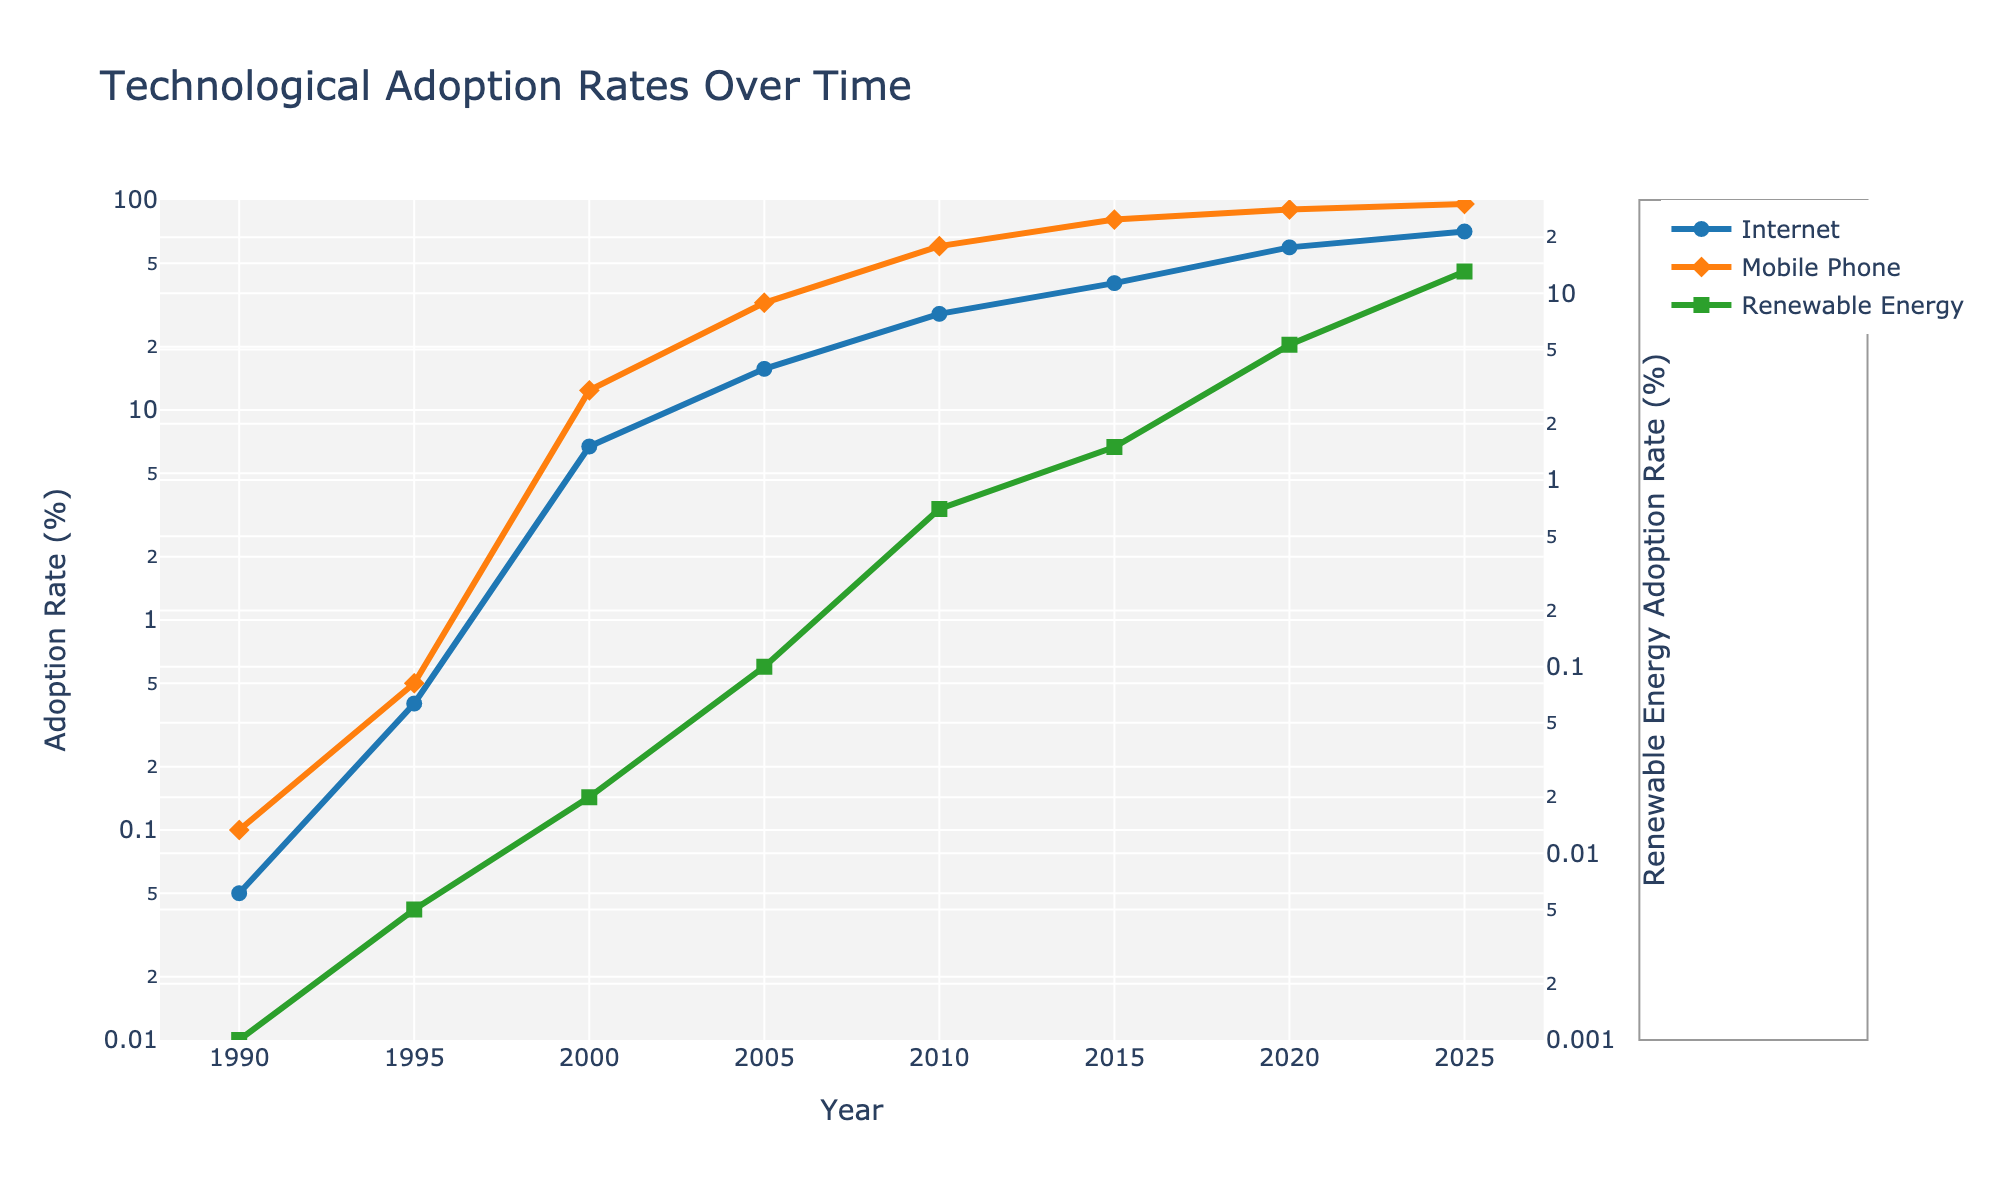What is the title of the figure? The figure's title is prominently displayed at the top of the plot.
Answer: Technological Adoption Rates Over Time What is the adoption rate of mobile phones in the year 2000? Locate the year 2000 on the x-axis, and then find the corresponding point on the mobile phone adoption curve (orange line) to determine the y-value.
Answer: 12.4% By how much did the renewable energy adoption rate increase from 1990 to 2005? Find the renewable energy adoption values for 1990 and 2005. Subtract the 1990 value from the 2005 value (0.1 - 0.001).
Answer: 0.099% Which technology had the fastest adoption rate between 1995 and 2000? Compare the slopes of the curves for all three technologies between 1995 and 2000. The steeper slope indicates the faster adoption rate.
Answer: Mobile Phones What is the adoption rate of the internet in 2020 compared to 2005? Find the internet adoption values for 2020 and 2005. Subtract the 2005 value from the 2020 value (59.5% - 15.7%).
Answer: 43.8% What is the range of the y-axis for the internet and mobile phone adoption rate? The y-axis for the internet and mobile phone adoption rate is logarithmic. It ranges from -2 to 2 in log scale, corresponding to roughly 0.01% to 100%.
Answer: 0.01% to 100% Which adoption rate reached above 1% first, mobile phones, the internet, or renewable energy? Find the point where each technology first crosses the 1% mark on the y-axis (log scale).
Answer: Mobile Phones How many years did it take for renewable energy adoption rates to reach above 1%? Identify the year when the renewable energy adoption rate first exceeded 1% and subtract the starting year (2015 - 1990).
Answer: 25 years What is the adoption rate of renewable energy in 2025? Locate the year 2025 on the x-axis and find the corresponding point on the renewable energy adoption curve (green line).
Answer: 13.1% Which technology had the highest adoption rate in 2010? Compare the adoption rates for all three technologies in 2010 and identify the highest value.
Answer: Mobile Phones 